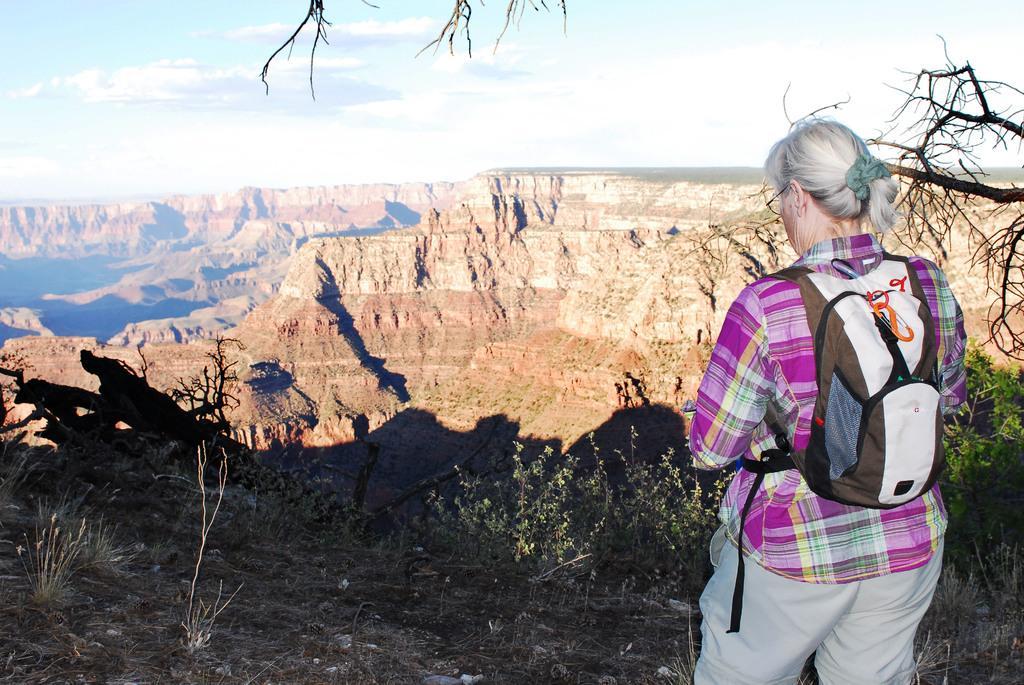Could you give a brief overview of what you see in this image? In this image we can see a woman standing and wearing a backpack, there are some plants, trees, grass and mountains, in the background we can see the sky with clouds. 